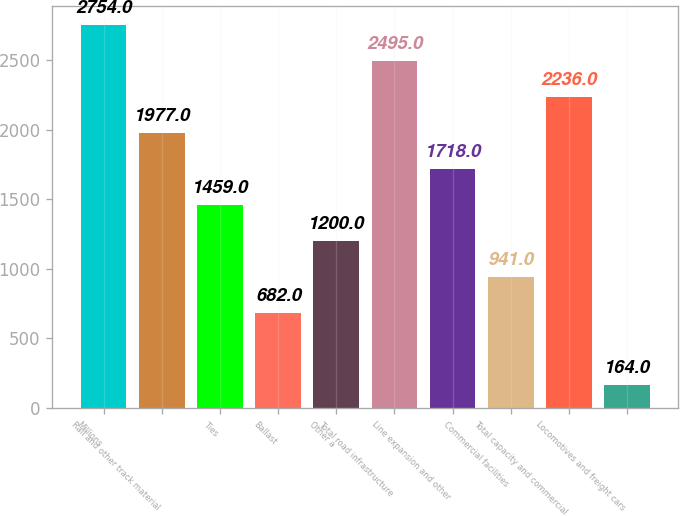<chart> <loc_0><loc_0><loc_500><loc_500><bar_chart><fcel>Millions<fcel>Rail and other track material<fcel>Ties<fcel>Ballast<fcel>Other a<fcel>Total road infrastructure<fcel>Line expansion and other<fcel>Commercial facilities<fcel>Total capacity and commercial<fcel>Locomotives and freight cars<nl><fcel>2754<fcel>1977<fcel>1459<fcel>682<fcel>1200<fcel>2495<fcel>1718<fcel>941<fcel>2236<fcel>164<nl></chart> 